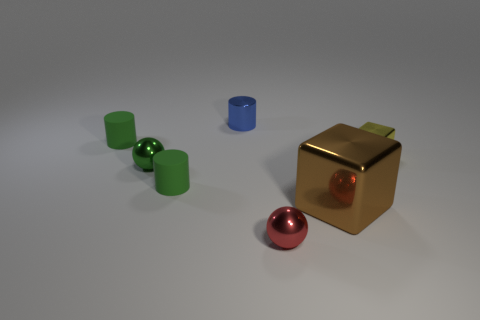What can you infer about the environment in which the objects are placed? The objects are placed in a neutral, minimalist environment with a light grey surface that might simulate a studio setup. There's no evidence of natural elements or everyday surroundings, hinting that this setting is likely constructed for presentation or photographic purposes. 